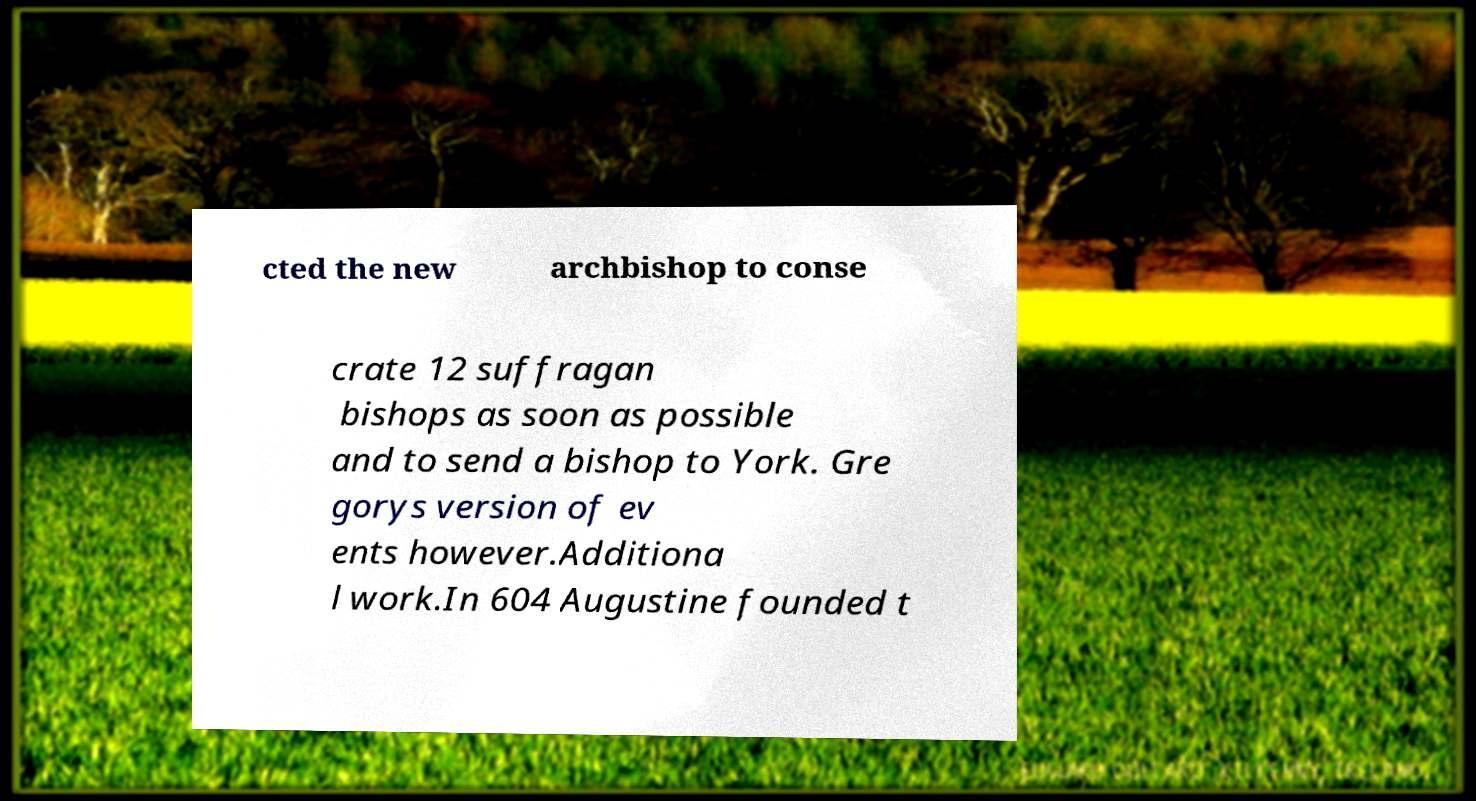For documentation purposes, I need the text within this image transcribed. Could you provide that? cted the new archbishop to conse crate 12 suffragan bishops as soon as possible and to send a bishop to York. Gre gorys version of ev ents however.Additiona l work.In 604 Augustine founded t 